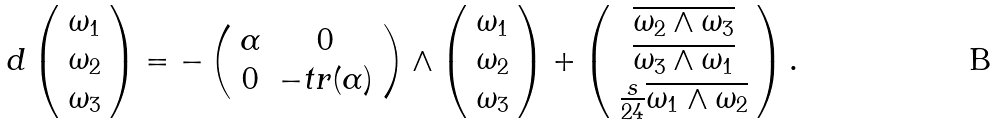Convert formula to latex. <formula><loc_0><loc_0><loc_500><loc_500>d \left ( \begin{array} { c } \omega _ { 1 } \\ \omega _ { 2 } \\ \omega _ { 3 } \end{array} \right ) = - \left ( \begin{array} { c c } \alpha & 0 \\ 0 & - t r ( \alpha ) \\ \end{array} \right ) \wedge \left ( \begin{array} { c } \omega _ { 1 } \\ \omega _ { 2 } \\ \omega _ { 3 } \end{array} \right ) + \left ( \begin{array} { c } \overline { \omega _ { 2 } \wedge \omega _ { 3 } } \\ \overline { \omega _ { 3 } \wedge \omega _ { 1 } } \\ \frac { s } { 2 4 } \overline { \omega _ { 1 } \wedge \omega _ { 2 } } \end{array} \right ) .</formula> 